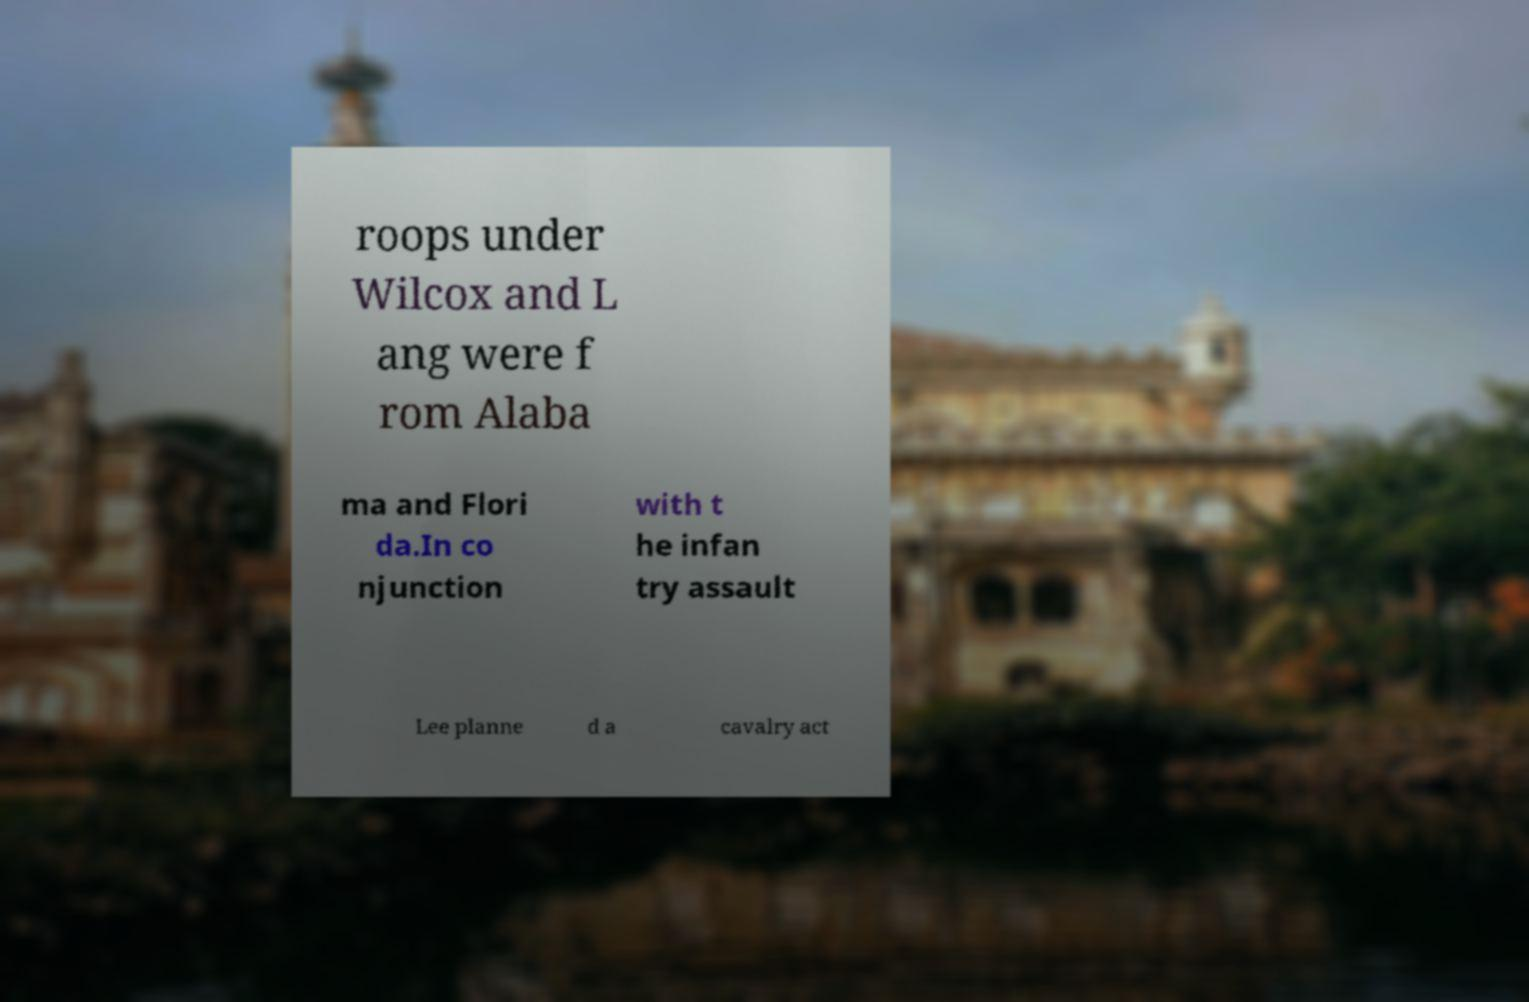What messages or text are displayed in this image? I need them in a readable, typed format. roops under Wilcox and L ang were f rom Alaba ma and Flori da.In co njunction with t he infan try assault Lee planne d a cavalry act 